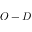Convert formula to latex. <formula><loc_0><loc_0><loc_500><loc_500>O - D</formula> 